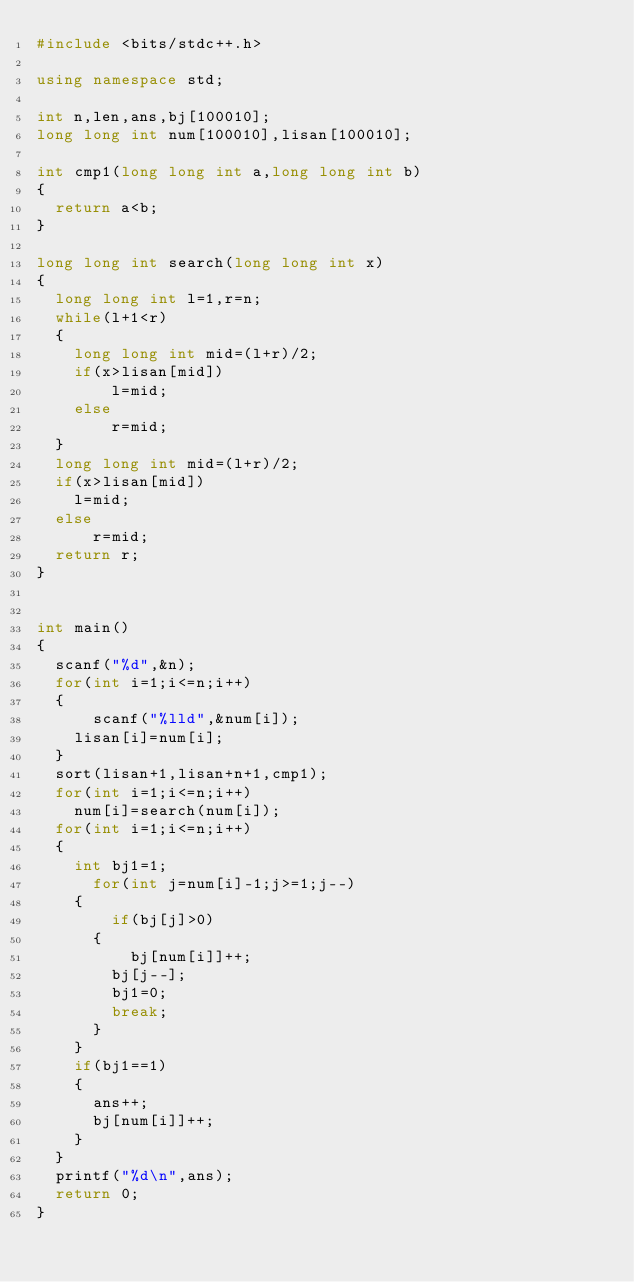<code> <loc_0><loc_0><loc_500><loc_500><_C++_>#include <bits/stdc++.h>

using namespace std;

int n,len,ans,bj[100010];
long long int num[100010],lisan[100010];

int cmp1(long long int a,long long int b)
{
	return a<b;
}

long long int search(long long int x)
{
	long long int l=1,r=n;
	while(l+1<r)
	{
		long long int mid=(l+r)/2;
		if(x>lisan[mid])
		    l=mid;
		else
		    r=mid;
	}
	long long int mid=(l+r)/2;
	if(x>lisan[mid])
		l=mid;
	else
	    r=mid;
	return r;
}


int main()
{
	scanf("%d",&n);
	for(int i=1;i<=n;i++)
	{
	    scanf("%lld",&num[i]);
		lisan[i]=num[i];	
	}    
	sort(lisan+1,lisan+n+1,cmp1);
	for(int i=1;i<=n;i++)
		num[i]=search(num[i]);
	for(int i=1;i<=n;i++)
	{
		int bj1=1;
	    for(int j=num[i]-1;j>=1;j--)
		{
		    if(bj[j]>0)
			{
			    bj[num[i]]++;
				bj[j--];
				bj1=0;
				break;	
			}	
		}	
		if(bj1==1)
		{
			ans++;
			bj[num[i]]++;
		}
	}
	printf("%d\n",ans);
	return 0;
} </code> 